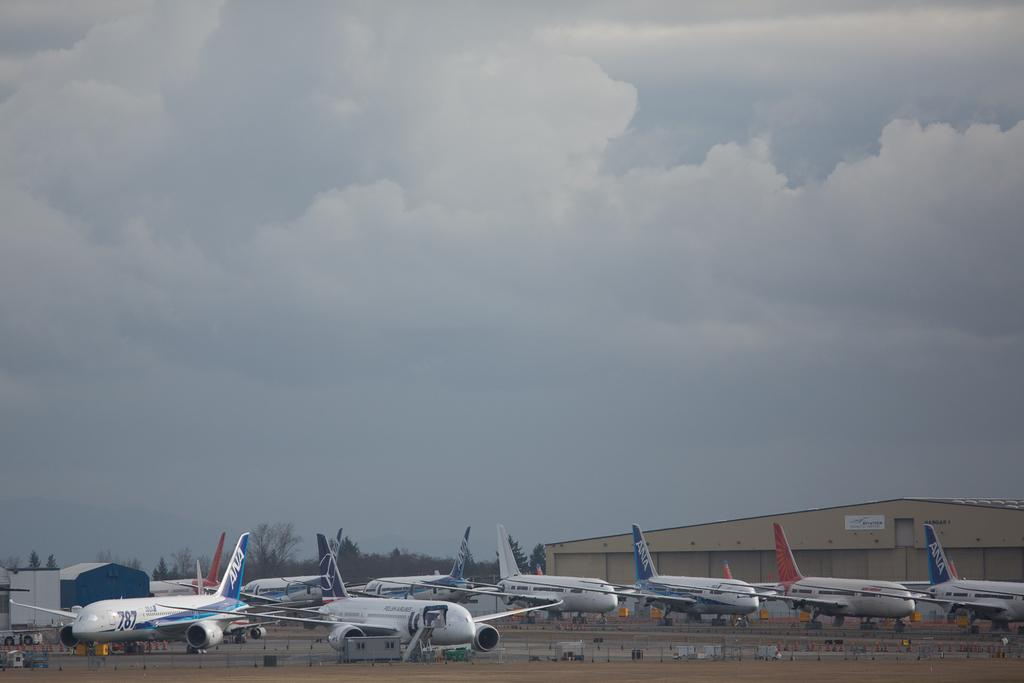Where was the picture taken? The picture was taken at an airport. What can be seen in the foreground of the image? There are airplanes, a runway, buildings, trees, and poles in the foreground of the image. What is the condition of the sky in the image? The sky is cloudy in the image. What grade does the airplane receive for its performance in the image? There is no indication of the airplane's performance in the image, so it cannot be graded. What color is the body of the airplane in the image? The color of the airplane's body cannot be determined from the image, as it is not mentioned in the provided facts. 